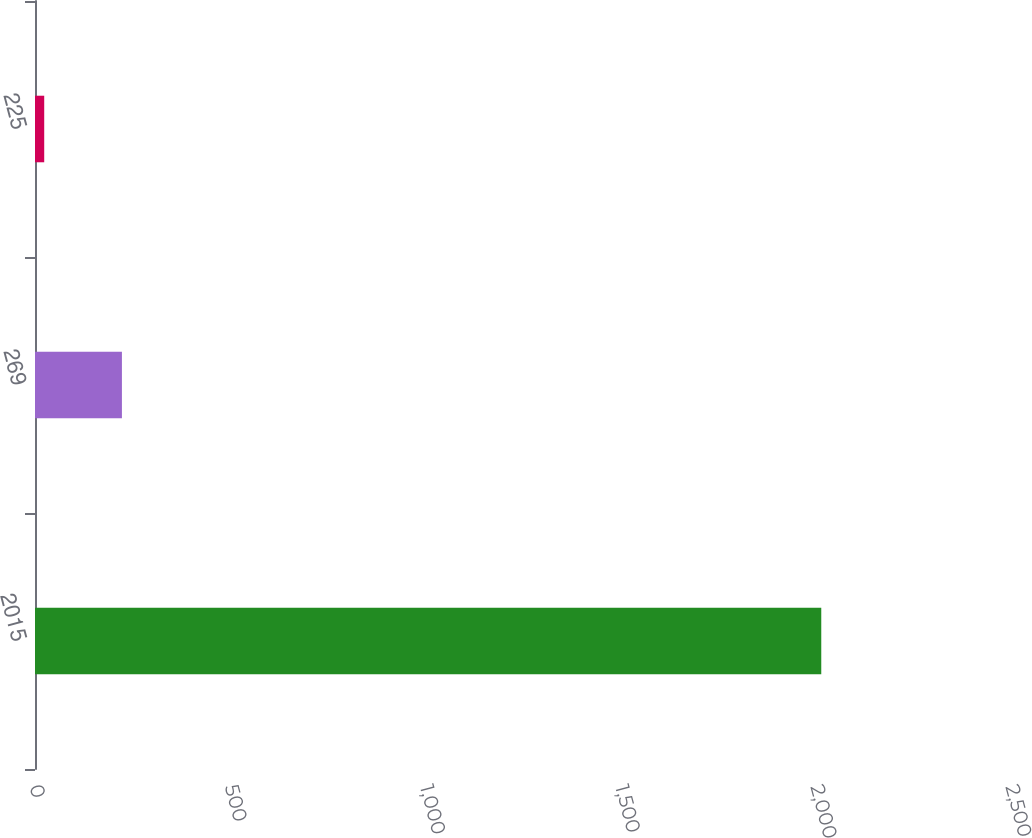Convert chart. <chart><loc_0><loc_0><loc_500><loc_500><bar_chart><fcel>2015<fcel>269<fcel>225<nl><fcel>2014<fcel>222.64<fcel>23.6<nl></chart> 